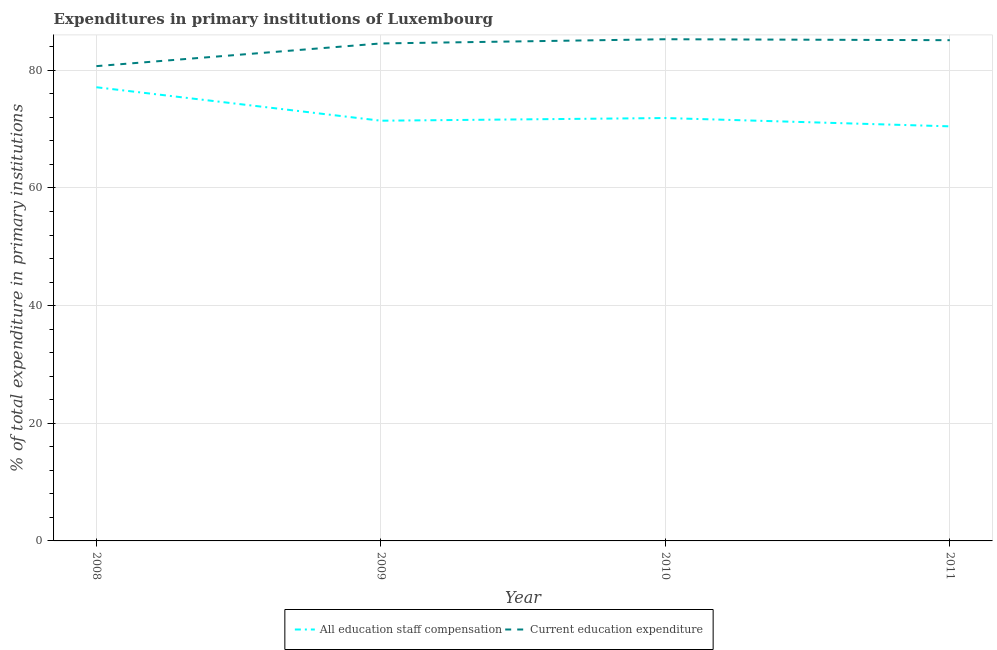What is the expenditure in staff compensation in 2010?
Make the answer very short. 71.89. Across all years, what is the maximum expenditure in education?
Ensure brevity in your answer.  85.29. Across all years, what is the minimum expenditure in education?
Keep it short and to the point. 80.72. What is the total expenditure in education in the graph?
Your response must be concise. 335.71. What is the difference between the expenditure in education in 2009 and that in 2011?
Your answer should be compact. -0.55. What is the difference between the expenditure in staff compensation in 2011 and the expenditure in education in 2008?
Ensure brevity in your answer.  -10.24. What is the average expenditure in education per year?
Give a very brief answer. 83.93. In the year 2011, what is the difference between the expenditure in education and expenditure in staff compensation?
Offer a terse response. 14.65. In how many years, is the expenditure in education greater than 24 %?
Ensure brevity in your answer.  4. What is the ratio of the expenditure in education in 2008 to that in 2009?
Give a very brief answer. 0.95. Is the difference between the expenditure in staff compensation in 2008 and 2010 greater than the difference between the expenditure in education in 2008 and 2010?
Offer a very short reply. Yes. What is the difference between the highest and the second highest expenditure in education?
Your answer should be compact. 0.16. What is the difference between the highest and the lowest expenditure in staff compensation?
Offer a terse response. 6.65. Does the expenditure in staff compensation monotonically increase over the years?
Your answer should be compact. No. Is the expenditure in staff compensation strictly greater than the expenditure in education over the years?
Your response must be concise. No. What is the difference between two consecutive major ticks on the Y-axis?
Your response must be concise. 20. Does the graph contain grids?
Provide a succinct answer. Yes. Where does the legend appear in the graph?
Provide a short and direct response. Bottom center. What is the title of the graph?
Ensure brevity in your answer.  Expenditures in primary institutions of Luxembourg. Does "Infant" appear as one of the legend labels in the graph?
Give a very brief answer. No. What is the label or title of the X-axis?
Make the answer very short. Year. What is the label or title of the Y-axis?
Offer a terse response. % of total expenditure in primary institutions. What is the % of total expenditure in primary institutions in All education staff compensation in 2008?
Keep it short and to the point. 77.13. What is the % of total expenditure in primary institutions of Current education expenditure in 2008?
Keep it short and to the point. 80.72. What is the % of total expenditure in primary institutions of All education staff compensation in 2009?
Provide a short and direct response. 71.44. What is the % of total expenditure in primary institutions in Current education expenditure in 2009?
Your answer should be compact. 84.57. What is the % of total expenditure in primary institutions of All education staff compensation in 2010?
Your answer should be very brief. 71.89. What is the % of total expenditure in primary institutions of Current education expenditure in 2010?
Your response must be concise. 85.29. What is the % of total expenditure in primary institutions of All education staff compensation in 2011?
Offer a very short reply. 70.48. What is the % of total expenditure in primary institutions of Current education expenditure in 2011?
Offer a very short reply. 85.13. Across all years, what is the maximum % of total expenditure in primary institutions in All education staff compensation?
Offer a very short reply. 77.13. Across all years, what is the maximum % of total expenditure in primary institutions of Current education expenditure?
Provide a short and direct response. 85.29. Across all years, what is the minimum % of total expenditure in primary institutions of All education staff compensation?
Keep it short and to the point. 70.48. Across all years, what is the minimum % of total expenditure in primary institutions in Current education expenditure?
Keep it short and to the point. 80.72. What is the total % of total expenditure in primary institutions in All education staff compensation in the graph?
Give a very brief answer. 290.94. What is the total % of total expenditure in primary institutions in Current education expenditure in the graph?
Your answer should be very brief. 335.71. What is the difference between the % of total expenditure in primary institutions in All education staff compensation in 2008 and that in 2009?
Your response must be concise. 5.69. What is the difference between the % of total expenditure in primary institutions in Current education expenditure in 2008 and that in 2009?
Provide a succinct answer. -3.86. What is the difference between the % of total expenditure in primary institutions in All education staff compensation in 2008 and that in 2010?
Your answer should be compact. 5.24. What is the difference between the % of total expenditure in primary institutions of Current education expenditure in 2008 and that in 2010?
Give a very brief answer. -4.57. What is the difference between the % of total expenditure in primary institutions of All education staff compensation in 2008 and that in 2011?
Your answer should be compact. 6.65. What is the difference between the % of total expenditure in primary institutions in Current education expenditure in 2008 and that in 2011?
Offer a very short reply. -4.41. What is the difference between the % of total expenditure in primary institutions in All education staff compensation in 2009 and that in 2010?
Offer a very short reply. -0.45. What is the difference between the % of total expenditure in primary institutions of Current education expenditure in 2009 and that in 2010?
Your answer should be very brief. -0.72. What is the difference between the % of total expenditure in primary institutions in All education staff compensation in 2009 and that in 2011?
Offer a terse response. 0.96. What is the difference between the % of total expenditure in primary institutions of Current education expenditure in 2009 and that in 2011?
Your answer should be very brief. -0.55. What is the difference between the % of total expenditure in primary institutions in All education staff compensation in 2010 and that in 2011?
Your answer should be compact. 1.41. What is the difference between the % of total expenditure in primary institutions of Current education expenditure in 2010 and that in 2011?
Provide a short and direct response. 0.16. What is the difference between the % of total expenditure in primary institutions in All education staff compensation in 2008 and the % of total expenditure in primary institutions in Current education expenditure in 2009?
Offer a very short reply. -7.45. What is the difference between the % of total expenditure in primary institutions of All education staff compensation in 2008 and the % of total expenditure in primary institutions of Current education expenditure in 2010?
Provide a short and direct response. -8.16. What is the difference between the % of total expenditure in primary institutions of All education staff compensation in 2008 and the % of total expenditure in primary institutions of Current education expenditure in 2011?
Offer a terse response. -8. What is the difference between the % of total expenditure in primary institutions of All education staff compensation in 2009 and the % of total expenditure in primary institutions of Current education expenditure in 2010?
Your answer should be compact. -13.85. What is the difference between the % of total expenditure in primary institutions of All education staff compensation in 2009 and the % of total expenditure in primary institutions of Current education expenditure in 2011?
Your response must be concise. -13.69. What is the difference between the % of total expenditure in primary institutions of All education staff compensation in 2010 and the % of total expenditure in primary institutions of Current education expenditure in 2011?
Ensure brevity in your answer.  -13.23. What is the average % of total expenditure in primary institutions in All education staff compensation per year?
Your answer should be compact. 72.73. What is the average % of total expenditure in primary institutions of Current education expenditure per year?
Your answer should be compact. 83.93. In the year 2008, what is the difference between the % of total expenditure in primary institutions in All education staff compensation and % of total expenditure in primary institutions in Current education expenditure?
Provide a succinct answer. -3.59. In the year 2009, what is the difference between the % of total expenditure in primary institutions in All education staff compensation and % of total expenditure in primary institutions in Current education expenditure?
Your answer should be compact. -13.14. In the year 2010, what is the difference between the % of total expenditure in primary institutions in All education staff compensation and % of total expenditure in primary institutions in Current education expenditure?
Make the answer very short. -13.4. In the year 2011, what is the difference between the % of total expenditure in primary institutions in All education staff compensation and % of total expenditure in primary institutions in Current education expenditure?
Offer a terse response. -14.65. What is the ratio of the % of total expenditure in primary institutions in All education staff compensation in 2008 to that in 2009?
Ensure brevity in your answer.  1.08. What is the ratio of the % of total expenditure in primary institutions of Current education expenditure in 2008 to that in 2009?
Offer a very short reply. 0.95. What is the ratio of the % of total expenditure in primary institutions of All education staff compensation in 2008 to that in 2010?
Keep it short and to the point. 1.07. What is the ratio of the % of total expenditure in primary institutions in Current education expenditure in 2008 to that in 2010?
Provide a succinct answer. 0.95. What is the ratio of the % of total expenditure in primary institutions in All education staff compensation in 2008 to that in 2011?
Provide a succinct answer. 1.09. What is the ratio of the % of total expenditure in primary institutions in Current education expenditure in 2008 to that in 2011?
Your response must be concise. 0.95. What is the ratio of the % of total expenditure in primary institutions of All education staff compensation in 2009 to that in 2010?
Provide a succinct answer. 0.99. What is the ratio of the % of total expenditure in primary institutions in All education staff compensation in 2009 to that in 2011?
Offer a terse response. 1.01. What is the ratio of the % of total expenditure in primary institutions of All education staff compensation in 2010 to that in 2011?
Offer a terse response. 1.02. What is the difference between the highest and the second highest % of total expenditure in primary institutions of All education staff compensation?
Provide a short and direct response. 5.24. What is the difference between the highest and the second highest % of total expenditure in primary institutions of Current education expenditure?
Make the answer very short. 0.16. What is the difference between the highest and the lowest % of total expenditure in primary institutions of All education staff compensation?
Offer a very short reply. 6.65. What is the difference between the highest and the lowest % of total expenditure in primary institutions in Current education expenditure?
Offer a very short reply. 4.57. 